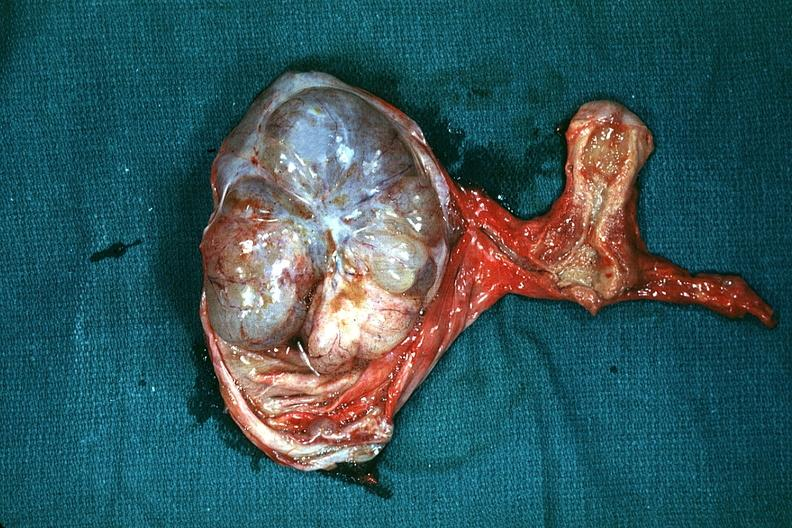what is in picture and thus illustrates the very large size of the ovarian tumor?
Answer the question using a single word or phrase. The excellent uterus 